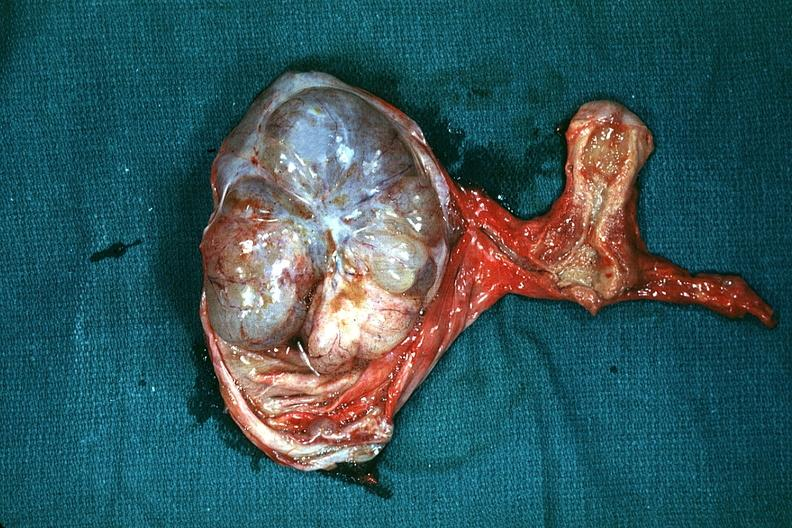what is in picture and thus illustrates the very large size of the ovarian tumor?
Answer the question using a single word or phrase. The excellent uterus 